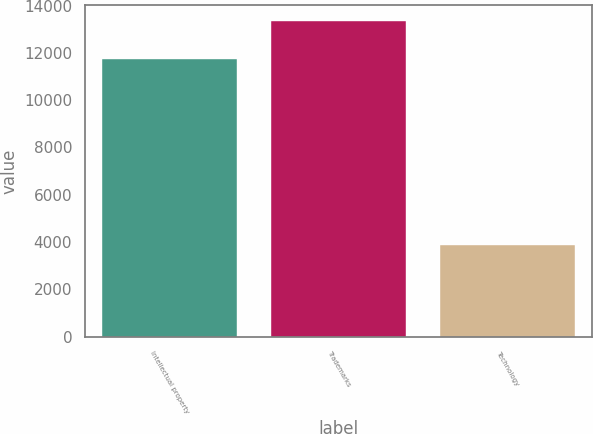Convert chart. <chart><loc_0><loc_0><loc_500><loc_500><bar_chart><fcel>Intellectual property<fcel>Trademarks<fcel>Technology<nl><fcel>11724<fcel>13339<fcel>3893<nl></chart> 